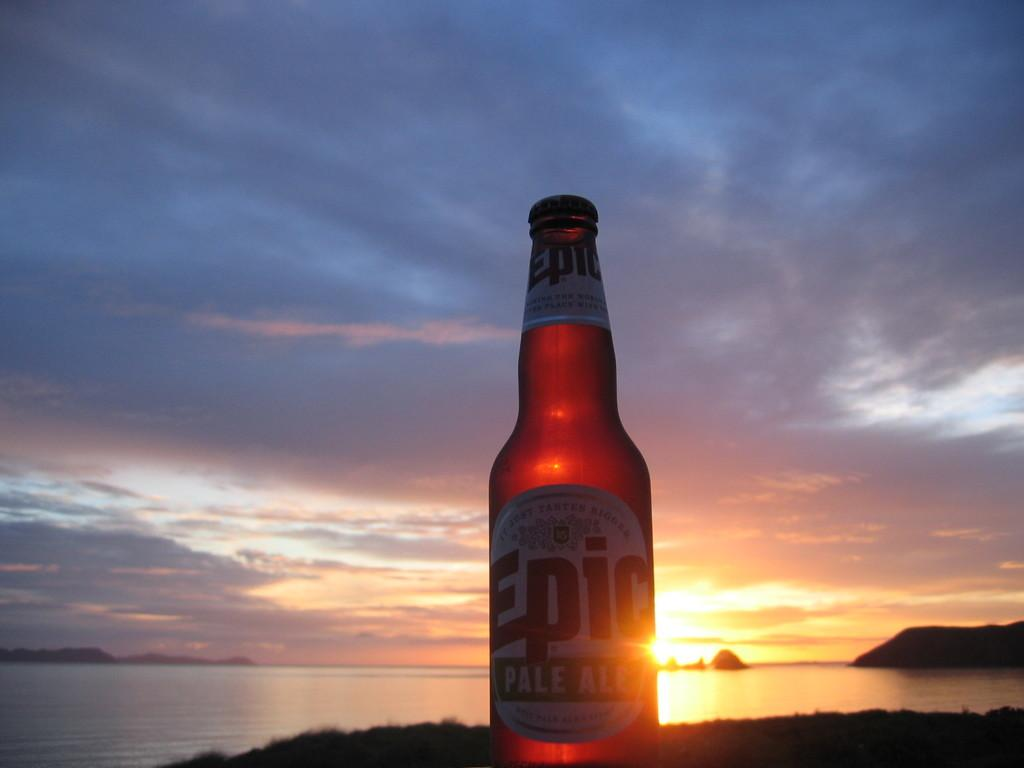<image>
Write a terse but informative summary of the picture. A bottle of Epic Pale Ale next to the sunset. 